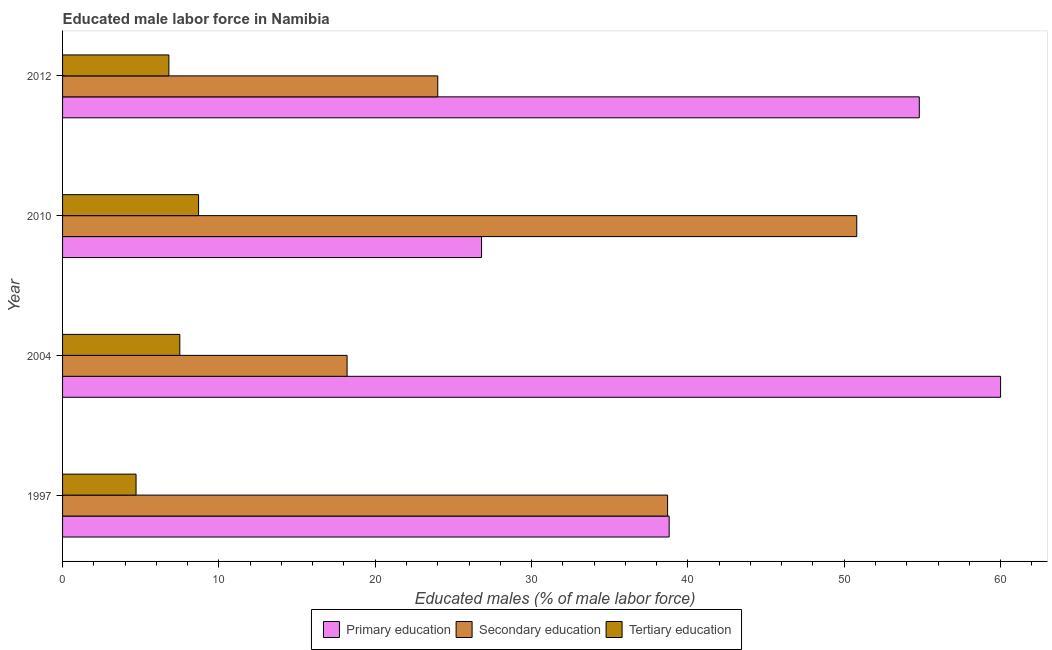How many groups of bars are there?
Offer a terse response. 4. How many bars are there on the 1st tick from the top?
Provide a short and direct response. 3. What is the label of the 2nd group of bars from the top?
Your response must be concise. 2010. In how many cases, is the number of bars for a given year not equal to the number of legend labels?
Provide a short and direct response. 0. Across all years, what is the maximum percentage of male labor force who received primary education?
Make the answer very short. 60. Across all years, what is the minimum percentage of male labor force who received secondary education?
Your answer should be compact. 18.2. In which year was the percentage of male labor force who received secondary education maximum?
Offer a very short reply. 2010. In which year was the percentage of male labor force who received tertiary education minimum?
Offer a very short reply. 1997. What is the total percentage of male labor force who received secondary education in the graph?
Provide a succinct answer. 131.7. What is the difference between the percentage of male labor force who received secondary education in 2004 and that in 2010?
Keep it short and to the point. -32.6. What is the difference between the percentage of male labor force who received primary education in 1997 and the percentage of male labor force who received tertiary education in 2010?
Provide a short and direct response. 30.1. What is the average percentage of male labor force who received primary education per year?
Offer a terse response. 45.1. In the year 2012, what is the difference between the percentage of male labor force who received primary education and percentage of male labor force who received secondary education?
Offer a very short reply. 30.8. What is the ratio of the percentage of male labor force who received primary education in 2004 to that in 2010?
Your answer should be compact. 2.24. What is the difference between the highest and the second highest percentage of male labor force who received secondary education?
Make the answer very short. 12.1. What is the difference between the highest and the lowest percentage of male labor force who received secondary education?
Your answer should be very brief. 32.6. In how many years, is the percentage of male labor force who received primary education greater than the average percentage of male labor force who received primary education taken over all years?
Make the answer very short. 2. Is the sum of the percentage of male labor force who received tertiary education in 1997 and 2010 greater than the maximum percentage of male labor force who received secondary education across all years?
Keep it short and to the point. No. What does the 2nd bar from the bottom in 1997 represents?
Offer a terse response. Secondary education. How many bars are there?
Your response must be concise. 12. How many years are there in the graph?
Your response must be concise. 4. Are the values on the major ticks of X-axis written in scientific E-notation?
Ensure brevity in your answer.  No. Does the graph contain any zero values?
Provide a succinct answer. No. Where does the legend appear in the graph?
Give a very brief answer. Bottom center. What is the title of the graph?
Offer a very short reply. Educated male labor force in Namibia. What is the label or title of the X-axis?
Your answer should be very brief. Educated males (% of male labor force). What is the Educated males (% of male labor force) in Primary education in 1997?
Ensure brevity in your answer.  38.8. What is the Educated males (% of male labor force) of Secondary education in 1997?
Your response must be concise. 38.7. What is the Educated males (% of male labor force) in Tertiary education in 1997?
Ensure brevity in your answer.  4.7. What is the Educated males (% of male labor force) of Primary education in 2004?
Your answer should be very brief. 60. What is the Educated males (% of male labor force) in Secondary education in 2004?
Your answer should be compact. 18.2. What is the Educated males (% of male labor force) in Primary education in 2010?
Give a very brief answer. 26.8. What is the Educated males (% of male labor force) of Secondary education in 2010?
Your response must be concise. 50.8. What is the Educated males (% of male labor force) in Tertiary education in 2010?
Keep it short and to the point. 8.7. What is the Educated males (% of male labor force) in Primary education in 2012?
Offer a terse response. 54.8. What is the Educated males (% of male labor force) in Secondary education in 2012?
Ensure brevity in your answer.  24. What is the Educated males (% of male labor force) of Tertiary education in 2012?
Make the answer very short. 6.8. Across all years, what is the maximum Educated males (% of male labor force) of Primary education?
Ensure brevity in your answer.  60. Across all years, what is the maximum Educated males (% of male labor force) of Secondary education?
Ensure brevity in your answer.  50.8. Across all years, what is the maximum Educated males (% of male labor force) in Tertiary education?
Offer a very short reply. 8.7. Across all years, what is the minimum Educated males (% of male labor force) of Primary education?
Make the answer very short. 26.8. Across all years, what is the minimum Educated males (% of male labor force) of Secondary education?
Provide a succinct answer. 18.2. Across all years, what is the minimum Educated males (% of male labor force) in Tertiary education?
Your answer should be very brief. 4.7. What is the total Educated males (% of male labor force) in Primary education in the graph?
Ensure brevity in your answer.  180.4. What is the total Educated males (% of male labor force) in Secondary education in the graph?
Your response must be concise. 131.7. What is the total Educated males (% of male labor force) of Tertiary education in the graph?
Your answer should be very brief. 27.7. What is the difference between the Educated males (% of male labor force) in Primary education in 1997 and that in 2004?
Offer a terse response. -21.2. What is the difference between the Educated males (% of male labor force) in Tertiary education in 1997 and that in 2004?
Keep it short and to the point. -2.8. What is the difference between the Educated males (% of male labor force) of Primary education in 1997 and that in 2010?
Ensure brevity in your answer.  12. What is the difference between the Educated males (% of male labor force) in Secondary education in 1997 and that in 2010?
Your answer should be compact. -12.1. What is the difference between the Educated males (% of male labor force) in Tertiary education in 1997 and that in 2010?
Keep it short and to the point. -4. What is the difference between the Educated males (% of male labor force) in Primary education in 1997 and that in 2012?
Give a very brief answer. -16. What is the difference between the Educated males (% of male labor force) of Secondary education in 1997 and that in 2012?
Your answer should be compact. 14.7. What is the difference between the Educated males (% of male labor force) of Primary education in 2004 and that in 2010?
Provide a succinct answer. 33.2. What is the difference between the Educated males (% of male labor force) in Secondary education in 2004 and that in 2010?
Make the answer very short. -32.6. What is the difference between the Educated males (% of male labor force) in Primary education in 2004 and that in 2012?
Give a very brief answer. 5.2. What is the difference between the Educated males (% of male labor force) of Tertiary education in 2004 and that in 2012?
Give a very brief answer. 0.7. What is the difference between the Educated males (% of male labor force) in Secondary education in 2010 and that in 2012?
Offer a terse response. 26.8. What is the difference between the Educated males (% of male labor force) in Tertiary education in 2010 and that in 2012?
Ensure brevity in your answer.  1.9. What is the difference between the Educated males (% of male labor force) in Primary education in 1997 and the Educated males (% of male labor force) in Secondary education in 2004?
Your answer should be compact. 20.6. What is the difference between the Educated males (% of male labor force) of Primary education in 1997 and the Educated males (% of male labor force) of Tertiary education in 2004?
Ensure brevity in your answer.  31.3. What is the difference between the Educated males (% of male labor force) of Secondary education in 1997 and the Educated males (% of male labor force) of Tertiary education in 2004?
Give a very brief answer. 31.2. What is the difference between the Educated males (% of male labor force) in Primary education in 1997 and the Educated males (% of male labor force) in Tertiary education in 2010?
Your answer should be compact. 30.1. What is the difference between the Educated males (% of male labor force) of Secondary education in 1997 and the Educated males (% of male labor force) of Tertiary education in 2010?
Ensure brevity in your answer.  30. What is the difference between the Educated males (% of male labor force) of Primary education in 1997 and the Educated males (% of male labor force) of Secondary education in 2012?
Provide a succinct answer. 14.8. What is the difference between the Educated males (% of male labor force) in Secondary education in 1997 and the Educated males (% of male labor force) in Tertiary education in 2012?
Provide a short and direct response. 31.9. What is the difference between the Educated males (% of male labor force) of Primary education in 2004 and the Educated males (% of male labor force) of Secondary education in 2010?
Ensure brevity in your answer.  9.2. What is the difference between the Educated males (% of male labor force) in Primary education in 2004 and the Educated males (% of male labor force) in Tertiary education in 2010?
Your answer should be very brief. 51.3. What is the difference between the Educated males (% of male labor force) of Primary education in 2004 and the Educated males (% of male labor force) of Secondary education in 2012?
Your answer should be compact. 36. What is the difference between the Educated males (% of male labor force) in Primary education in 2004 and the Educated males (% of male labor force) in Tertiary education in 2012?
Your response must be concise. 53.2. What is the difference between the Educated males (% of male labor force) of Primary education in 2010 and the Educated males (% of male labor force) of Tertiary education in 2012?
Provide a succinct answer. 20. What is the difference between the Educated males (% of male labor force) of Secondary education in 2010 and the Educated males (% of male labor force) of Tertiary education in 2012?
Your response must be concise. 44. What is the average Educated males (% of male labor force) in Primary education per year?
Your answer should be very brief. 45.1. What is the average Educated males (% of male labor force) of Secondary education per year?
Your answer should be very brief. 32.92. What is the average Educated males (% of male labor force) in Tertiary education per year?
Keep it short and to the point. 6.92. In the year 1997, what is the difference between the Educated males (% of male labor force) of Primary education and Educated males (% of male labor force) of Secondary education?
Offer a terse response. 0.1. In the year 1997, what is the difference between the Educated males (% of male labor force) of Primary education and Educated males (% of male labor force) of Tertiary education?
Give a very brief answer. 34.1. In the year 2004, what is the difference between the Educated males (% of male labor force) in Primary education and Educated males (% of male labor force) in Secondary education?
Ensure brevity in your answer.  41.8. In the year 2004, what is the difference between the Educated males (% of male labor force) in Primary education and Educated males (% of male labor force) in Tertiary education?
Provide a short and direct response. 52.5. In the year 2004, what is the difference between the Educated males (% of male labor force) in Secondary education and Educated males (% of male labor force) in Tertiary education?
Your answer should be compact. 10.7. In the year 2010, what is the difference between the Educated males (% of male labor force) in Secondary education and Educated males (% of male labor force) in Tertiary education?
Your answer should be compact. 42.1. In the year 2012, what is the difference between the Educated males (% of male labor force) in Primary education and Educated males (% of male labor force) in Secondary education?
Provide a succinct answer. 30.8. In the year 2012, what is the difference between the Educated males (% of male labor force) in Secondary education and Educated males (% of male labor force) in Tertiary education?
Give a very brief answer. 17.2. What is the ratio of the Educated males (% of male labor force) of Primary education in 1997 to that in 2004?
Provide a succinct answer. 0.65. What is the ratio of the Educated males (% of male labor force) in Secondary education in 1997 to that in 2004?
Provide a succinct answer. 2.13. What is the ratio of the Educated males (% of male labor force) of Tertiary education in 1997 to that in 2004?
Your response must be concise. 0.63. What is the ratio of the Educated males (% of male labor force) in Primary education in 1997 to that in 2010?
Your answer should be very brief. 1.45. What is the ratio of the Educated males (% of male labor force) of Secondary education in 1997 to that in 2010?
Your answer should be compact. 0.76. What is the ratio of the Educated males (% of male labor force) of Tertiary education in 1997 to that in 2010?
Keep it short and to the point. 0.54. What is the ratio of the Educated males (% of male labor force) in Primary education in 1997 to that in 2012?
Provide a succinct answer. 0.71. What is the ratio of the Educated males (% of male labor force) of Secondary education in 1997 to that in 2012?
Your answer should be very brief. 1.61. What is the ratio of the Educated males (% of male labor force) of Tertiary education in 1997 to that in 2012?
Ensure brevity in your answer.  0.69. What is the ratio of the Educated males (% of male labor force) of Primary education in 2004 to that in 2010?
Your answer should be very brief. 2.24. What is the ratio of the Educated males (% of male labor force) in Secondary education in 2004 to that in 2010?
Make the answer very short. 0.36. What is the ratio of the Educated males (% of male labor force) in Tertiary education in 2004 to that in 2010?
Provide a short and direct response. 0.86. What is the ratio of the Educated males (% of male labor force) in Primary education in 2004 to that in 2012?
Offer a very short reply. 1.09. What is the ratio of the Educated males (% of male labor force) of Secondary education in 2004 to that in 2012?
Give a very brief answer. 0.76. What is the ratio of the Educated males (% of male labor force) in Tertiary education in 2004 to that in 2012?
Provide a succinct answer. 1.1. What is the ratio of the Educated males (% of male labor force) in Primary education in 2010 to that in 2012?
Offer a terse response. 0.49. What is the ratio of the Educated males (% of male labor force) of Secondary education in 2010 to that in 2012?
Provide a short and direct response. 2.12. What is the ratio of the Educated males (% of male labor force) in Tertiary education in 2010 to that in 2012?
Your answer should be compact. 1.28. What is the difference between the highest and the second highest Educated males (% of male labor force) of Secondary education?
Keep it short and to the point. 12.1. What is the difference between the highest and the second highest Educated males (% of male labor force) of Tertiary education?
Ensure brevity in your answer.  1.2. What is the difference between the highest and the lowest Educated males (% of male labor force) in Primary education?
Your response must be concise. 33.2. What is the difference between the highest and the lowest Educated males (% of male labor force) in Secondary education?
Your answer should be very brief. 32.6. 